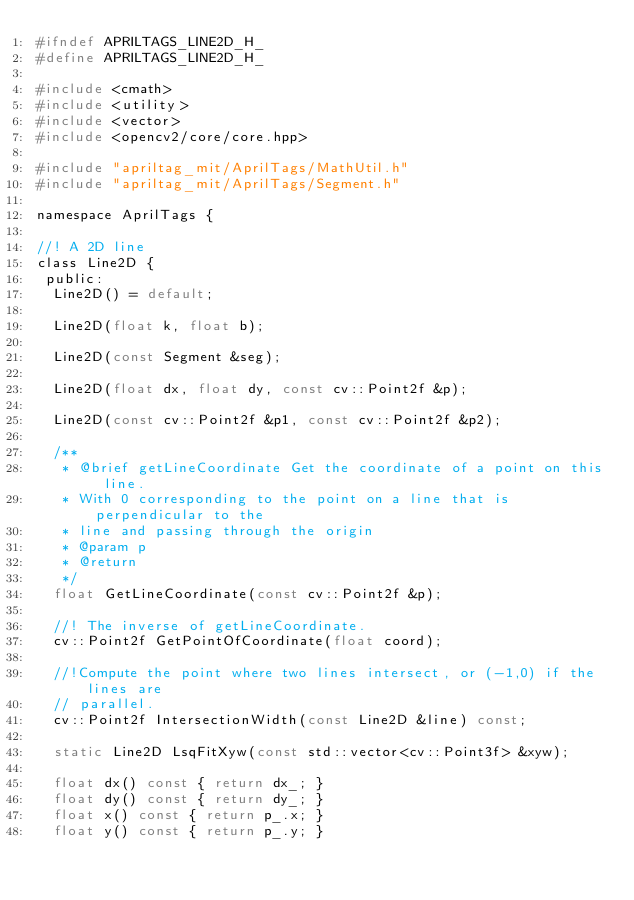<code> <loc_0><loc_0><loc_500><loc_500><_C_>#ifndef APRILTAGS_LINE2D_H_
#define APRILTAGS_LINE2D_H_

#include <cmath>
#include <utility>
#include <vector>
#include <opencv2/core/core.hpp>

#include "apriltag_mit/AprilTags/MathUtil.h"
#include "apriltag_mit/AprilTags/Segment.h"

namespace AprilTags {

//! A 2D line
class Line2D {
 public:
  Line2D() = default;

  Line2D(float k, float b);

  Line2D(const Segment &seg);

  Line2D(float dx, float dy, const cv::Point2f &p);

  Line2D(const cv::Point2f &p1, const cv::Point2f &p2);

  /**
   * @brief getLineCoordinate Get the coordinate of a point on this line.
   * With 0 corresponding to the point on a line that is perpendicular to the
   * line and passing through the origin
   * @param p
   * @return
   */
  float GetLineCoordinate(const cv::Point2f &p);

  //! The inverse of getLineCoordinate.
  cv::Point2f GetPointOfCoordinate(float coord);

  //!Compute the point where two lines intersect, or (-1,0) if the lines are
  // parallel.
  cv::Point2f IntersectionWidth(const Line2D &line) const;

  static Line2D LsqFitXyw(const std::vector<cv::Point3f> &xyw);

  float dx() const { return dx_; }
  float dy() const { return dy_; }
  float x() const { return p_.x; }
  float y() const { return p_.y; }</code> 